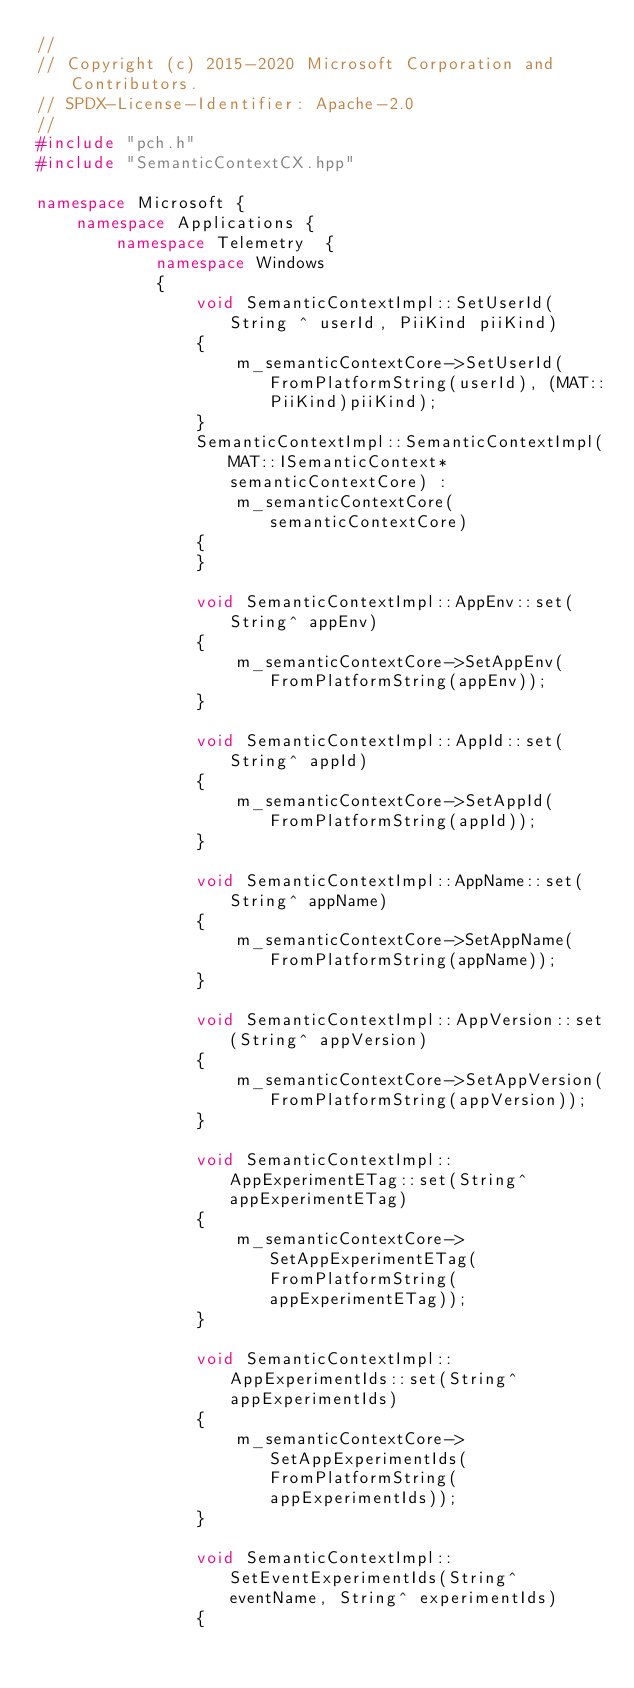Convert code to text. <code><loc_0><loc_0><loc_500><loc_500><_C++_>//
// Copyright (c) 2015-2020 Microsoft Corporation and Contributors.
// SPDX-License-Identifier: Apache-2.0
//
#include "pch.h"
#include "SemanticContextCX.hpp"

namespace Microsoft {
    namespace Applications {
        namespace Telemetry  {
            namespace Windows
            {
                void SemanticContextImpl::SetUserId(String ^ userId, PiiKind piiKind)
                {
                    m_semanticContextCore->SetUserId(FromPlatformString(userId), (MAT::PiiKind)piiKind);
                }
                SemanticContextImpl::SemanticContextImpl(MAT::ISemanticContext* semanticContextCore) :
                    m_semanticContextCore(semanticContextCore)
                {
                }

                void SemanticContextImpl::AppEnv::set(String^ appEnv)
                {
                    m_semanticContextCore->SetAppEnv(FromPlatformString(appEnv));
                }

                void SemanticContextImpl::AppId::set(String^ appId)
                {
                    m_semanticContextCore->SetAppId(FromPlatformString(appId));
                }

                void SemanticContextImpl::AppName::set(String^ appName)
                {
                    m_semanticContextCore->SetAppName(FromPlatformString(appName));
                }

                void SemanticContextImpl::AppVersion::set(String^ appVersion)
                {
                    m_semanticContextCore->SetAppVersion(FromPlatformString(appVersion));
                }

                void SemanticContextImpl::AppExperimentETag::set(String^ appExperimentETag)
                {
                    m_semanticContextCore->SetAppExperimentETag(FromPlatformString(appExperimentETag));
                }

                void SemanticContextImpl::AppExperimentIds::set(String^ appExperimentIds)
                {
                    m_semanticContextCore->SetAppExperimentIds(FromPlatformString(appExperimentIds));
                }

                void SemanticContextImpl::SetEventExperimentIds(String^ eventName, String^ experimentIds)
                {</code> 